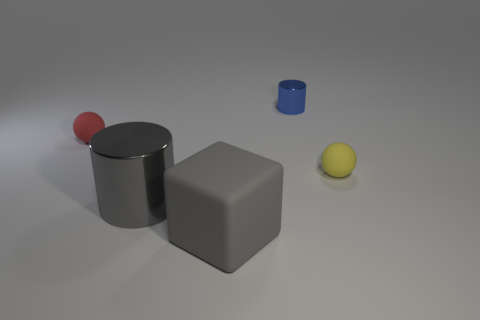Add 3 small red objects. How many objects exist? 8 Subtract all red balls. How many balls are left? 1 Subtract 1 cylinders. How many cylinders are left? 1 Subtract all cylinders. How many objects are left? 3 Subtract all red cylinders. How many red spheres are left? 1 Subtract all purple rubber things. Subtract all matte things. How many objects are left? 2 Add 2 red matte balls. How many red matte balls are left? 3 Add 5 blue objects. How many blue objects exist? 6 Subtract 0 cyan cubes. How many objects are left? 5 Subtract all yellow cylinders. Subtract all purple spheres. How many cylinders are left? 2 